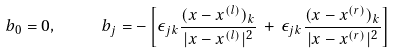<formula> <loc_0><loc_0><loc_500><loc_500>b _ { 0 } = 0 , \quad \ b _ { j } = - \left [ \epsilon _ { j k } \frac { ( x - x ^ { ( l ) } ) _ { k } } { | x - x ^ { ( l ) } | ^ { 2 } } \, + \, \epsilon _ { j k } \frac { ( x - x ^ { ( r ) } ) _ { k } } { | x - x ^ { ( r ) } | ^ { 2 } } \right ]</formula> 